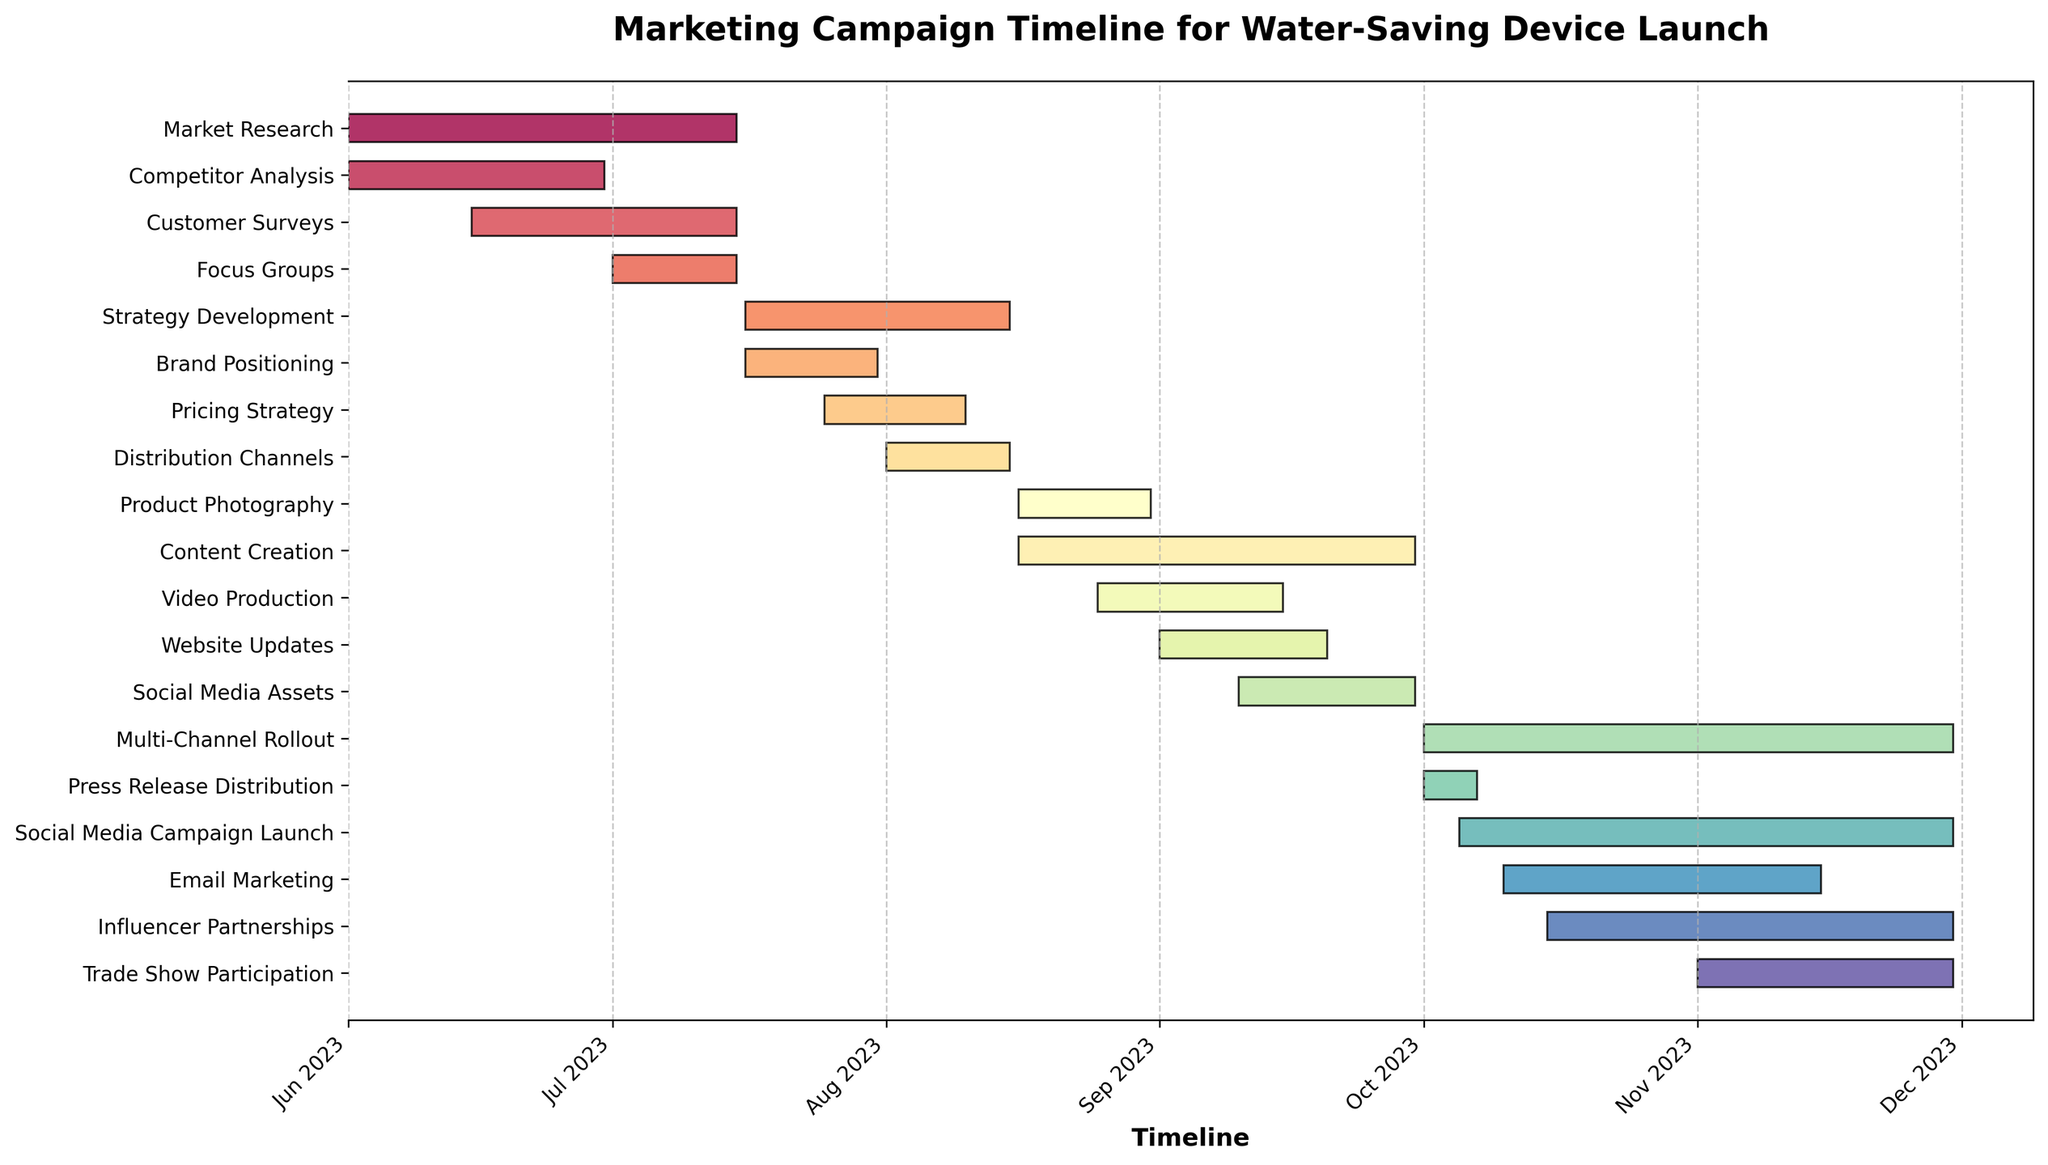What's the title of the figure? The title is typically found at the top of a chart. In this case, the title "Marketing Campaign Timeline for Water-Saving Device Launch" is displayed prominently.
Answer: Marketing Campaign Timeline for Water-Saving Device Launch What are the start and end dates of the "Content Creation" phase? To find the start and end dates, look for the "Content Creation" bar, which is positioned on the y-axis. The bar indicates the phase starts on "2023-08-16" and ends on "2023-09-30."
Answer: 2023-08-16 to 2023-09-30 Which task overlaps with the "Pricing Strategy" the most? To determine the overlapping task, find "Pricing Strategy," noting it runs from "2023-07-25" to "2023-08-10." "Brand Positioning" overlaps entirely with this period from "2023-07-16" to "2023-07-31."
Answer: Brand Positioning How long is the "Email Marketing" phase? The duration is calculated by subtracting the start date from the end date. For "Email Marketing," starting on "2023-10-10" and ending on "2023-11-15," the duration is 36 days.
Answer: 36 days Which tasks are scheduled for October 2023? Tasks scheduled in October are identified by bars spanning October on the timeline. The tasks include "Multi-Channel Rollout," "Press Release Distribution," "Social Media Campaign Launch," "Email Marketing," and "Influencer Partnerships."
Answer: Multi-Channel Rollout, Press Release Distribution, Social Media Campaign Launch, Email Marketing, Influencer Partnerships What's the shortest task in the timeline? By comparing the lengths of all bars, "Press Release Distribution" is found to be the shortest, lasting from "2023-10-01" to "2023-10-07," which is 7 days.
Answer: Press Release Distribution Are there any tasks that start and end in the same month? To find these tasks, identify bars that start and end within a single month. "Competitor Analysis" (June 2023), "Brand Positioning" (July 2023), "Product Photography" (August 2023), "Press Release Distribution" (October 2023), and "Trade Show Participation" (November 2023) meet this criterion.
Answer: Competitor Analysis, Brand Positioning, Product Photography, Press Release Distribution, Trade Show Participation Compare the duration of "Social Media Campaign Launch" and "Video Production." Which one is longer? The duration of each task is calculated and compared. "Social Media Campaign Launch" runs from "2023-10-05" to "2023-11-30" (57 days), while "Video Production" spans "2023-08-25" to "2023-09-15" (22 days). Thus, "Social Media Campaign Launch" is longer.
Answer: Social Media Campaign Launch How does the "Strategy Development" phase align with the "Focus Groups" phase? To compare, locate "Strategy Development" (2023-07-16 to 2023-08-15) and "Focus Groups" (2023-07-01 to 2023-07-15). "Strategy Development" starts the day after "Focus Groups" ends.
Answer: Starts the day after Focus Groups ends 